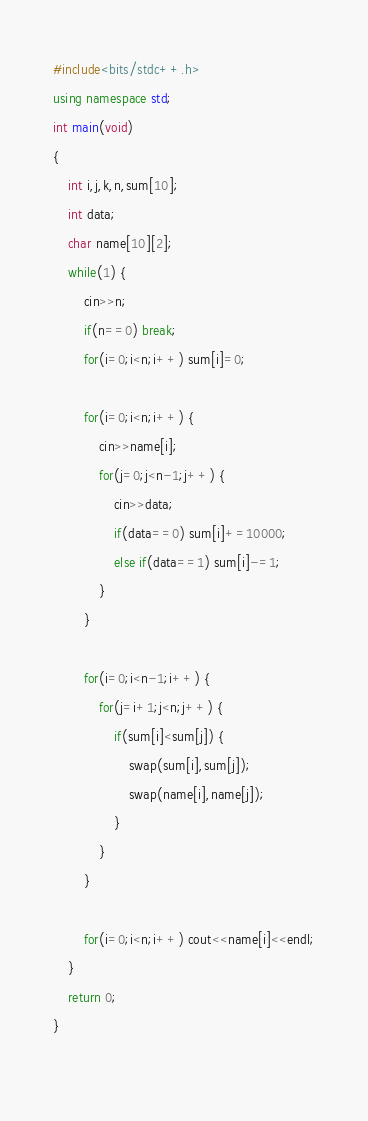<code> <loc_0><loc_0><loc_500><loc_500><_C++_>#include<bits/stdc++.h>
using namespace std;
int main(void)
{
	int i,j,k,n,sum[10];
	int data;
	char name[10][2];
	while(1) {
		cin>>n;
		if(n==0) break;
		for(i=0;i<n;i++) sum[i]=0;
		
		for(i=0;i<n;i++) {
			cin>>name[i];
			for(j=0;j<n-1;j++) {
				cin>>data;
				if(data==0) sum[i]+=10000;
				else if(data==1) sum[i]-=1;
			}
		}
		
		for(i=0;i<n-1;i++) {
			for(j=i+1;j<n;j++) {
				if(sum[i]<sum[j]) {
					swap(sum[i],sum[j]);
					swap(name[i],name[j]);
				}
			}
		}
		
		for(i=0;i<n;i++) cout<<name[i]<<endl;
	}
	return 0;
}
	</code> 